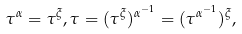<formula> <loc_0><loc_0><loc_500><loc_500>\tau ^ { \alpha } = \tau ^ { \xi } , \tau = ( \tau ^ { \xi } ) ^ { \alpha ^ { - 1 } } = ( \tau ^ { \alpha ^ { - 1 } } ) ^ { \xi } ,</formula> 